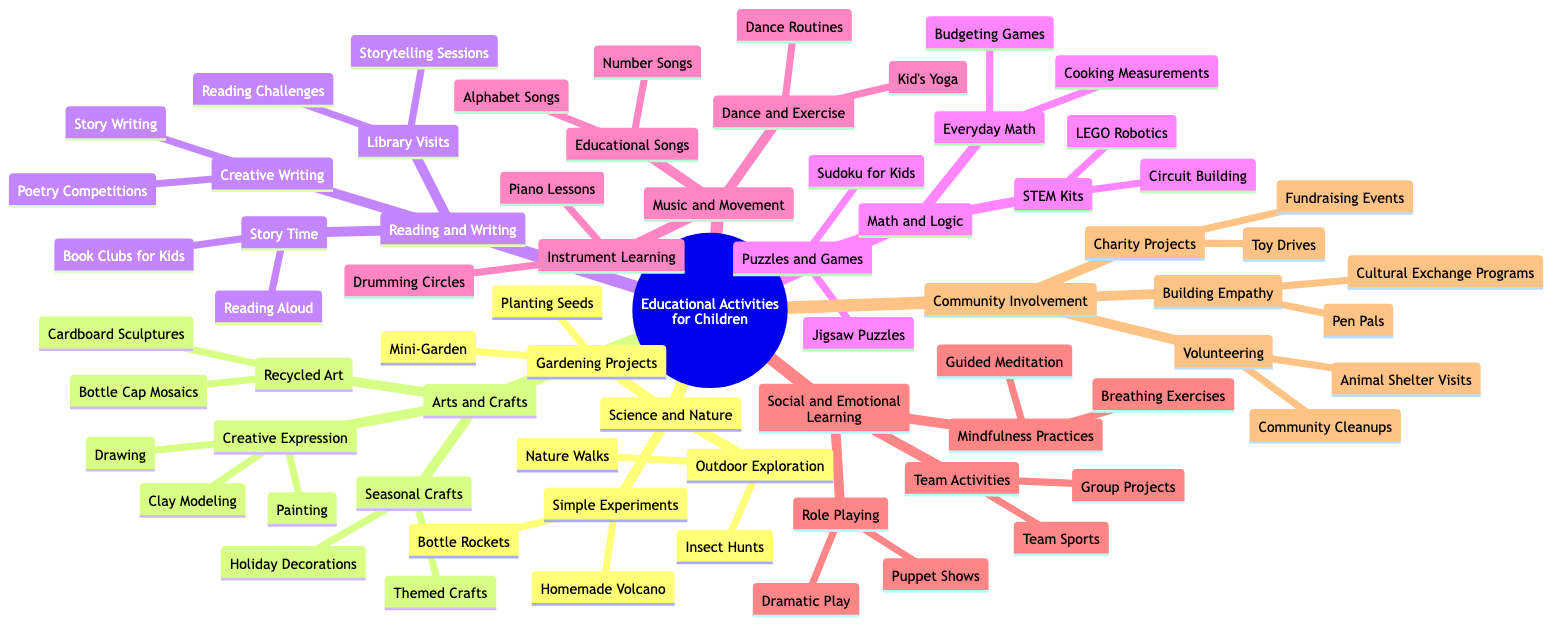What are three categories of educational activities for children? The diagram lists several categories at the main level, including Science and Nature, Arts and Crafts, and Reading and Writing. These are the first three branches off the main topic.
Answer: Science and Nature, Arts and Crafts, Reading and Writing How many activities are listed under "Music and Movement"? Under the "Music and Movement" category, there are three subcategories: Educational Songs, Instrument Learning, and Dance and Exercise. Counting all subcategories shows a total of three activities listed.
Answer: 3 What type of projects fall under "Community Involvement"? The "Community Involvement" category includes three distinct subcategories: Charity Projects, Volunteering, and Building Empathy. Each subcategory represents different activities structured around community engagement.
Answer: Charity Projects, Volunteering, Building Empathy Which category contains "Bottle Rockets"? "Bottle Rockets" is listed under the "Simple Experiments" subcategory, which itself is a part of the "Science and Nature" category. To find the answer, we locate "Bottle Rockets" and trace back its hierarchical relationship in the diagram.
Answer: Science and Nature What are two activities included in "Creative Writing"? Under the "Creative Writing" subcategory, there are two listed activities: Story Writing and Poetry Competitions. Both activities are specifically outlined as part of the learning concept.
Answer: Story Writing, Poetry Competitions Which category emphasizes "Mindfulness Practices"? The "Mindfulness Practices" activity is located within the "Social and Emotional Learning" category. By identifying the subcategories of this category, we find mindfulness practices listed as one of the activities.
Answer: Social and Emotional Learning What is the total number of major categories in the diagram? The diagram outlines a total of six major categories under which various activities are grouped. By counting these primary branches, we arrive at the total.
Answer: 6 How does "Gardening Projects" relate to "Outdoor Exploration"? "Gardening Projects" is another subcategory under "Science and Nature," while "Outdoor Exploration" is also a subcategory within the same parent category. This relationship illustrates that both are methods of exploring science through nature.
Answer: Both are subcategories of Science and Nature 